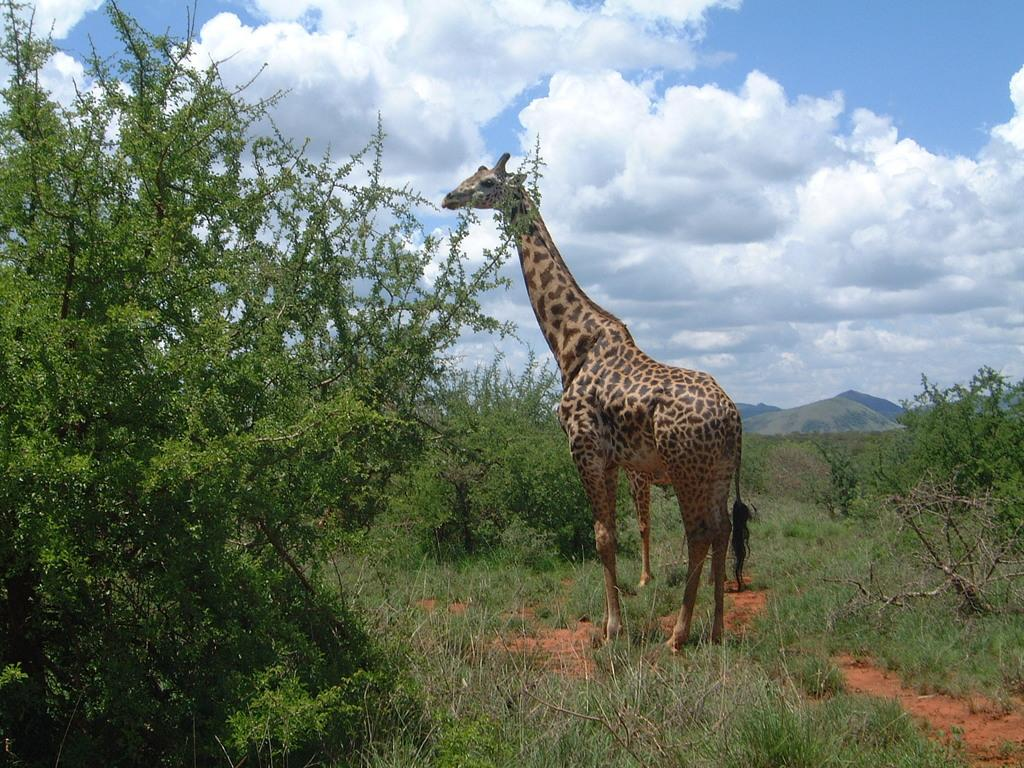What animal is the main subject of the image? There is a giraffe in the image. Where is the giraffe located? The giraffe is standing on a grassland. What type of vegetation can be seen in the image? There are plants in the image. What can be seen in the distance in the image? There are mountains in the background of the image, and the sky is visible as well. What type of twig is the giraffe holding in its mouth in the image? There is no twig present in the image; the giraffe is not holding anything in its mouth. 